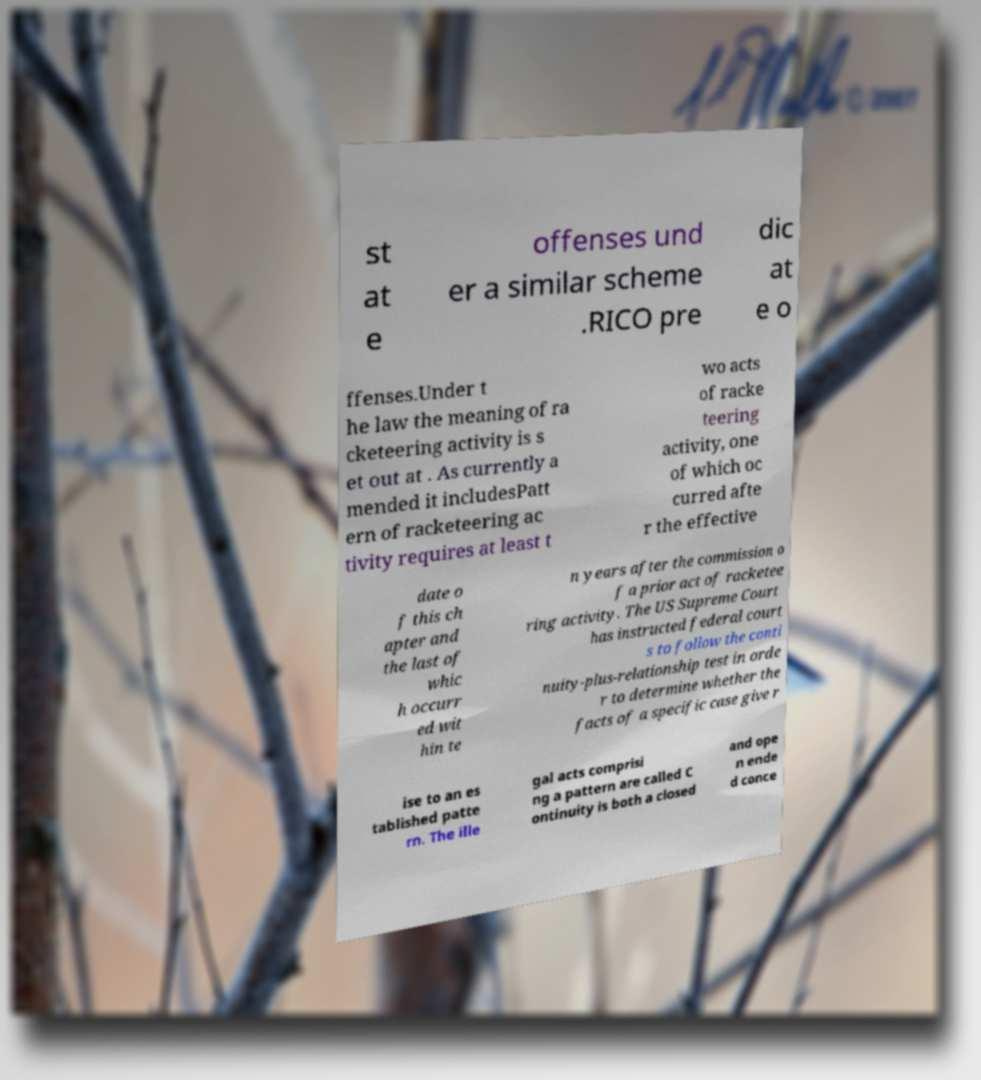There's text embedded in this image that I need extracted. Can you transcribe it verbatim? st at e offenses und er a similar scheme .RICO pre dic at e o ffenses.Under t he law the meaning of ra cketeering activity is s et out at . As currently a mended it includesPatt ern of racketeering ac tivity requires at least t wo acts of racke teering activity, one of which oc curred afte r the effective date o f this ch apter and the last of whic h occurr ed wit hin te n years after the commission o f a prior act of racketee ring activity. The US Supreme Court has instructed federal court s to follow the conti nuity-plus-relationship test in orde r to determine whether the facts of a specific case give r ise to an es tablished patte rn. The ille gal acts comprisi ng a pattern are called C ontinuity is both a closed and ope n ende d conce 